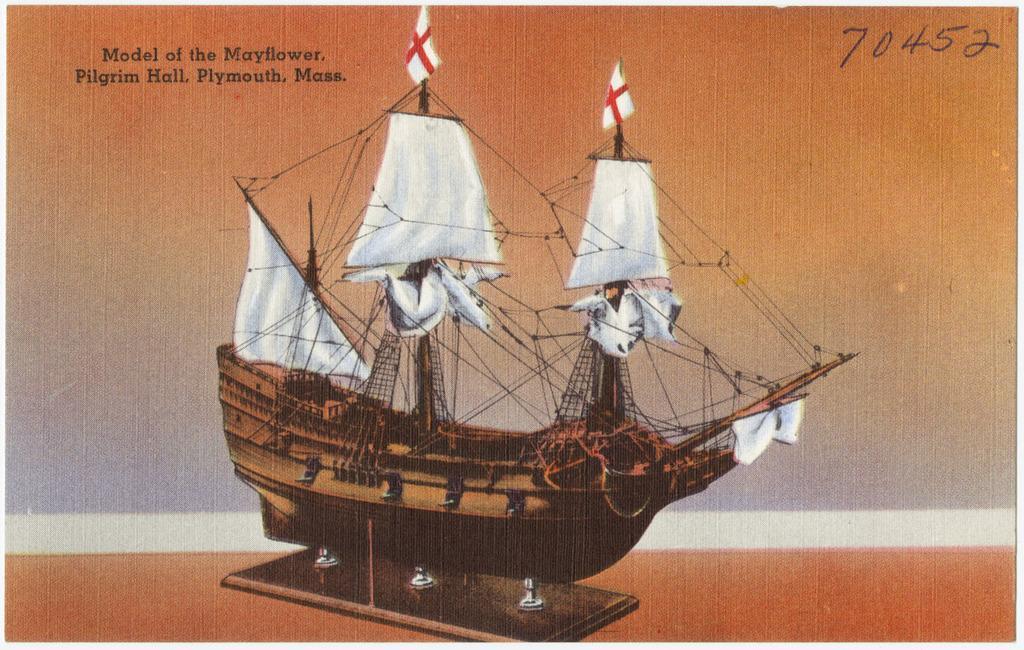Describe this image in one or two sentences. In this image we can see a picture of a ship containing some poles, ropes, flags and in the background we can see some text and numbers. 